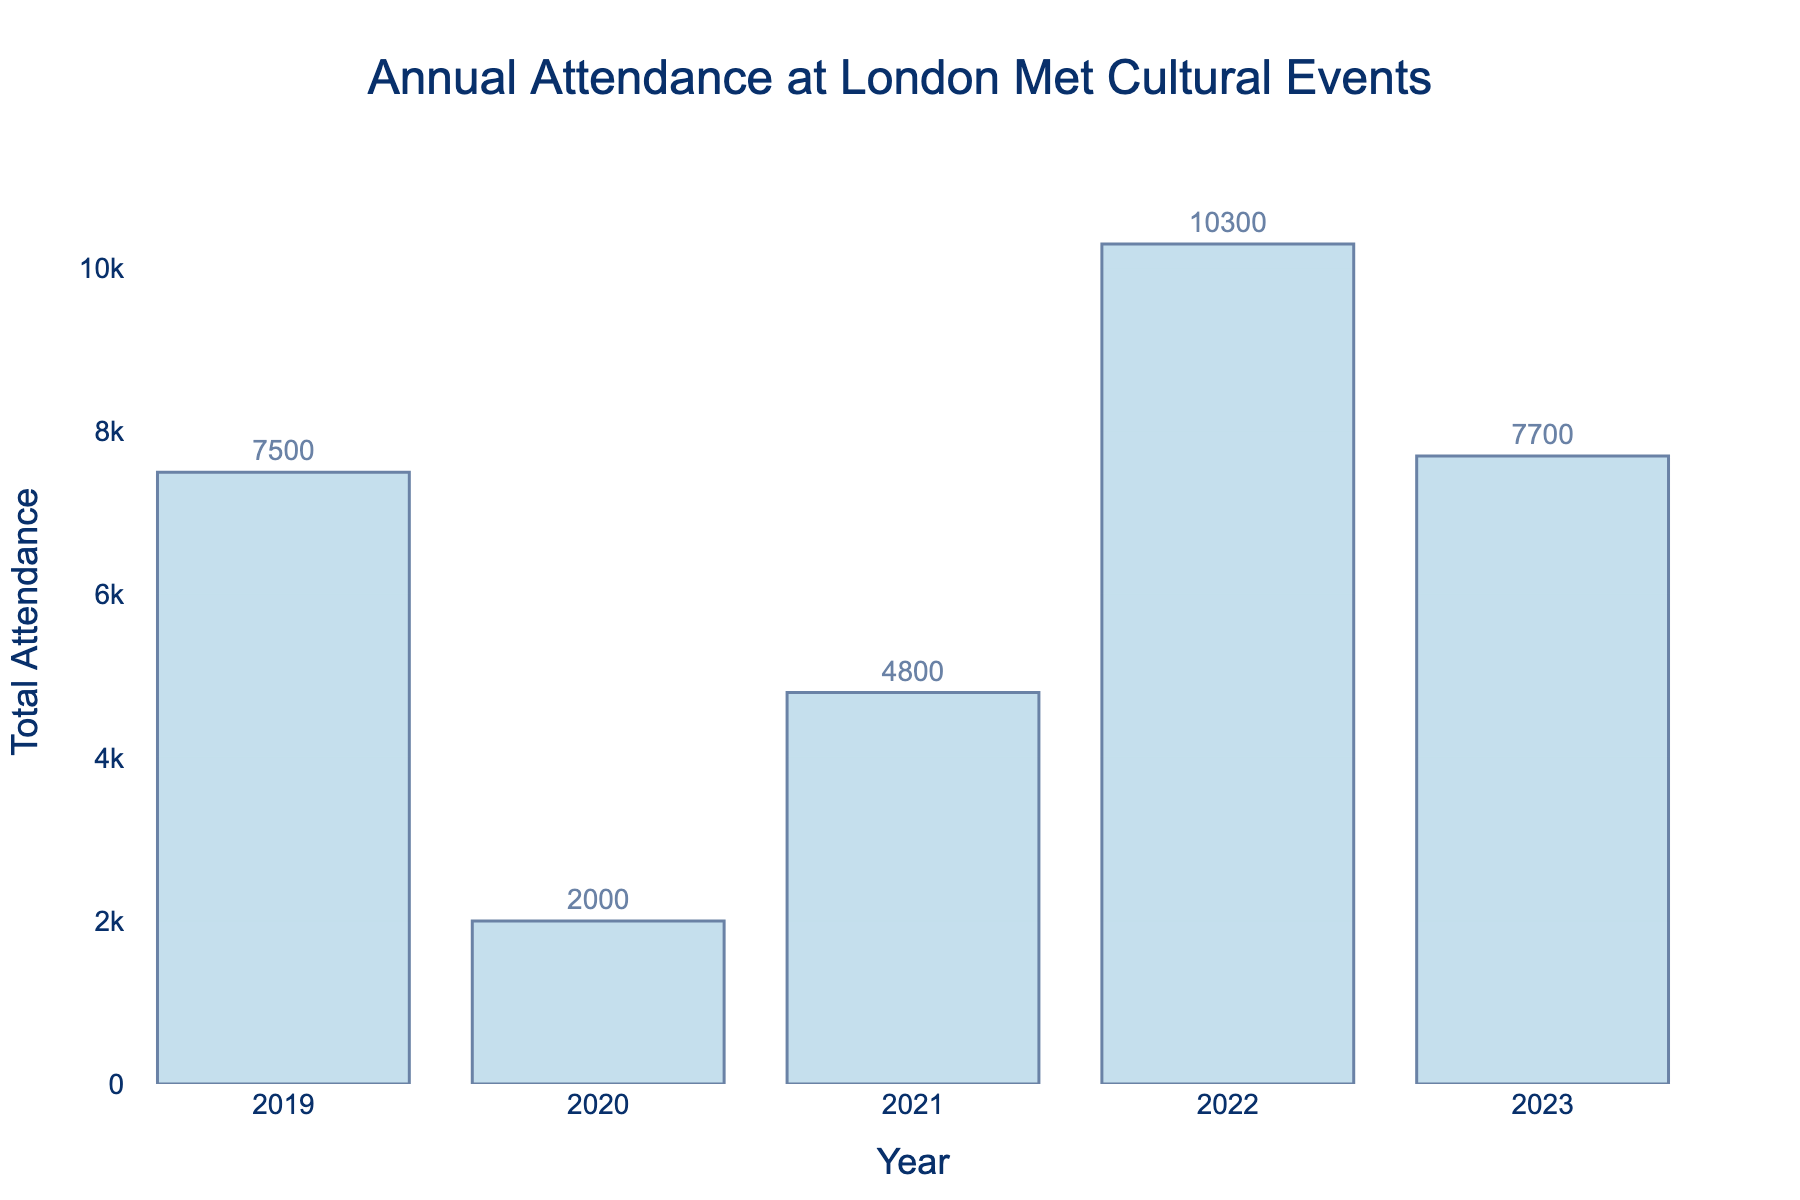What year had the highest total attendance? By looking at the figure, identify the bar with the greatest height, which represents the highest total attendance.
Answer: 2022 How does the total attendance of 2021 compare to 2020? Compare the heights of the bars for the years 2021 and 2020. The bar for 2021 is higher than the bar for 2020, indicating a higher total attendance.
Answer: Higher What is the total attendance increase from 2020 to 2022? Identify the attendance value for 2020 and 2022 from the bars, then subtract the 2020 value from the 2022 value. 2022 is 10300 and 2020 is 2000. The increase is 10300 - 2000 = 8300.
Answer: 8300 What is the average attendance across all the years shown? Add the attendance values for each year and divide by the number of years. (7500 + 2000 + 4800 + 10300+ 7700) / 5 = 32300 / 5 = 6460.
Answer: 6460 Is 2023's total attendance closer to 2021's or 2022's? Compare 2023 attendance to both 2021 and 2022. 2023 is 7700, 2021 is 4800, and 2022 is 10300. The difference between 2023 and 2021 is 2900, and for 2022 is 2600. 2023 is closer to 2022.
Answer: 2022 Has the attendance shown a general upward or downward trend over the past 5 years? Refer to the order of attendance values over the 5 years and observe the trend. Most recent years show increased attendance compared to earlier years.
Answer: Upward By how much did attendance increase from 2019 to 2023? Identify the attendance values for 2019 and 2023 and subtract the 2019 value from the 2023 value. 2019 is 7500 and 2023 is 7700. The increase is 7700 - 7500 = 200.
Answer: 200 Which year had the lowest total attendance? Look at the figure and find the bar with the smallest height, representing the lowest total attendance.
Answer: 2020 How much larger is 2022's attendance compared to 2019's? Subtract the 2019 attendance from the 2022 attendance. 10300 (2022) - 7500 (2019) = 2800.
Answer: 2800 What is the difference between the highest and lowest total attendance years? Identify the highest (10300 in 2022) and lowest (2000 in 2020) attendance values and subtract the smallest from the largest. 10300 - 2000 = 8300.
Answer: 8300 